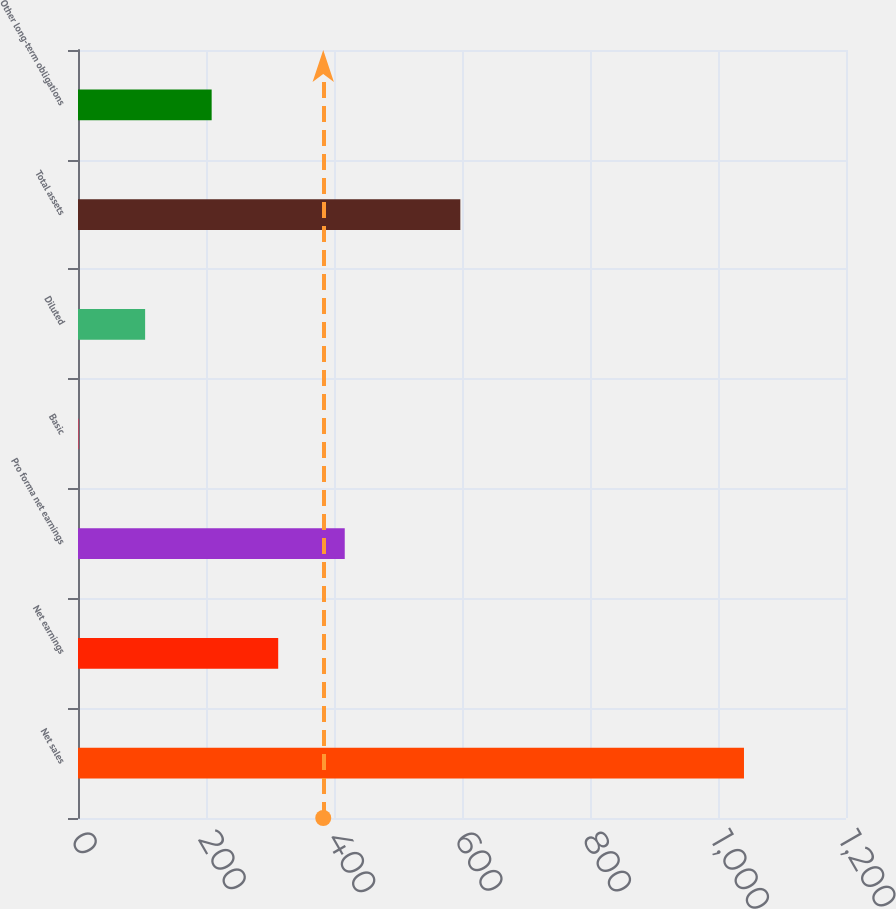Convert chart to OTSL. <chart><loc_0><loc_0><loc_500><loc_500><bar_chart><fcel>Net sales<fcel>Net earnings<fcel>Pro forma net earnings<fcel>Basic<fcel>Diluted<fcel>Total assets<fcel>Other long-term obligations<nl><fcel>1040.6<fcel>312.82<fcel>416.79<fcel>0.91<fcel>104.88<fcel>597.4<fcel>208.85<nl></chart> 